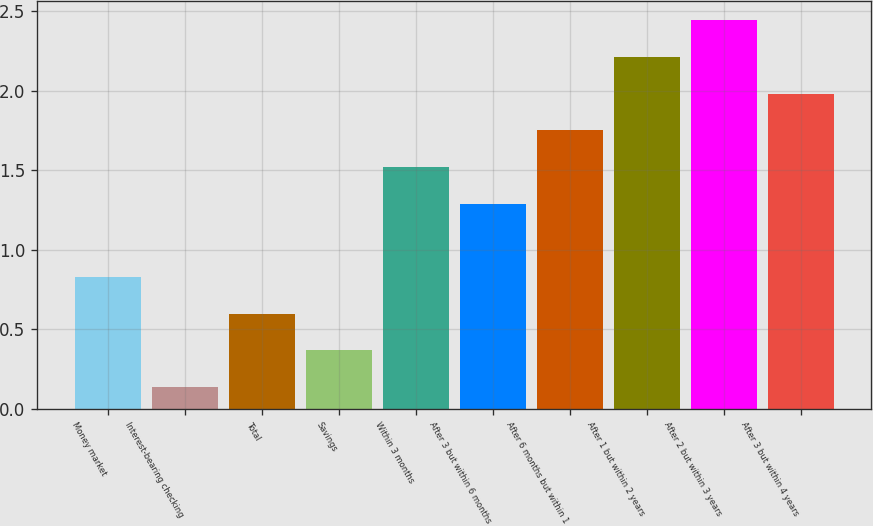Convert chart. <chart><loc_0><loc_0><loc_500><loc_500><bar_chart><fcel>Money market<fcel>Interest-bearing checking<fcel>Total<fcel>Savings<fcel>Within 3 months<fcel>After 3 but within 6 months<fcel>After 6 months but within 1<fcel>After 1 but within 2 years<fcel>After 2 but within 3 years<fcel>After 3 but within 4 years<nl><fcel>0.83<fcel>0.14<fcel>0.6<fcel>0.37<fcel>1.52<fcel>1.29<fcel>1.75<fcel>2.21<fcel>2.44<fcel>1.98<nl></chart> 